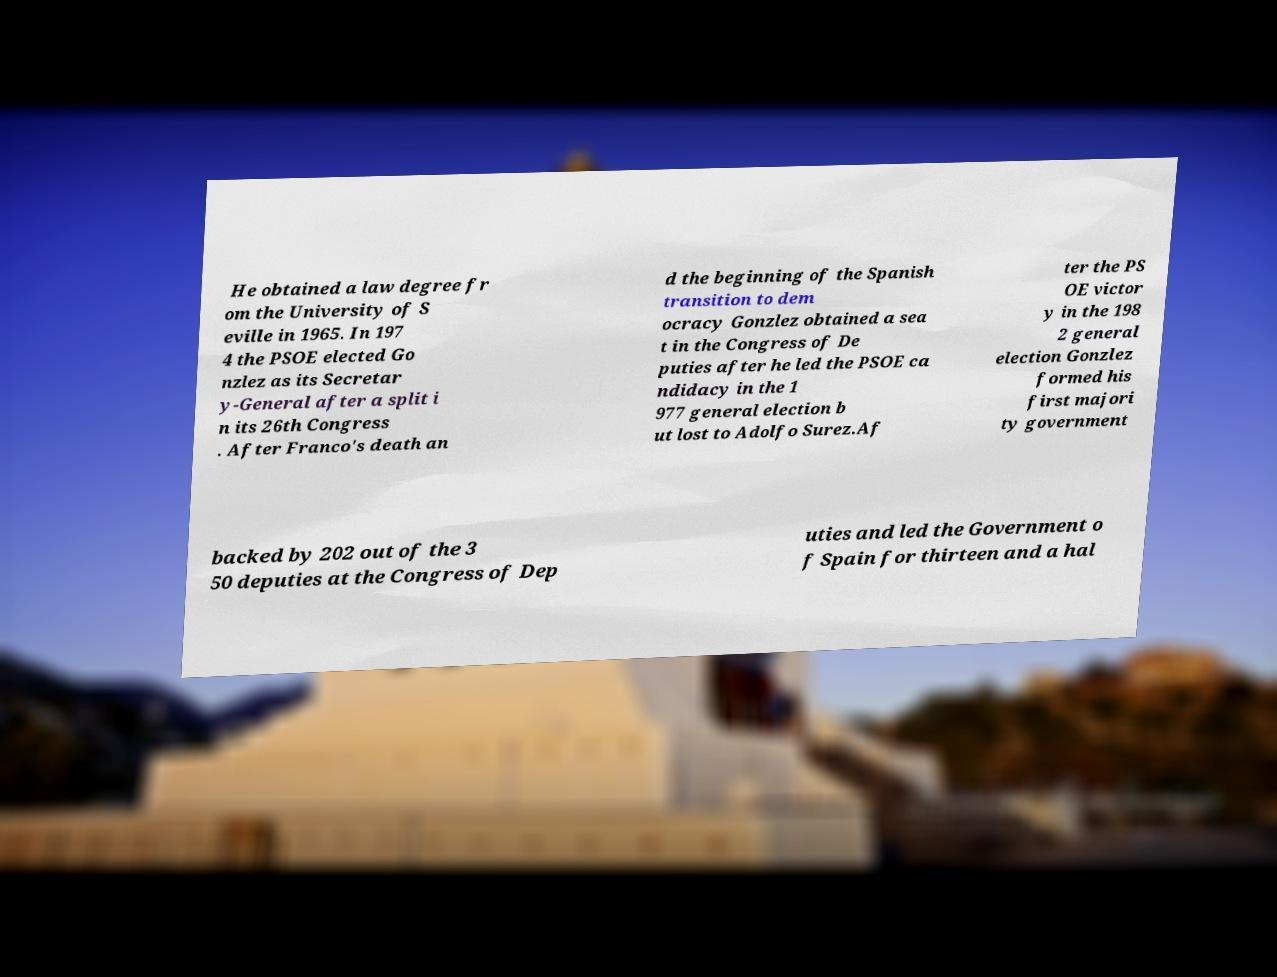There's text embedded in this image that I need extracted. Can you transcribe it verbatim? He obtained a law degree fr om the University of S eville in 1965. In 197 4 the PSOE elected Go nzlez as its Secretar y-General after a split i n its 26th Congress . After Franco's death an d the beginning of the Spanish transition to dem ocracy Gonzlez obtained a sea t in the Congress of De puties after he led the PSOE ca ndidacy in the 1 977 general election b ut lost to Adolfo Surez.Af ter the PS OE victor y in the 198 2 general election Gonzlez formed his first majori ty government backed by 202 out of the 3 50 deputies at the Congress of Dep uties and led the Government o f Spain for thirteen and a hal 